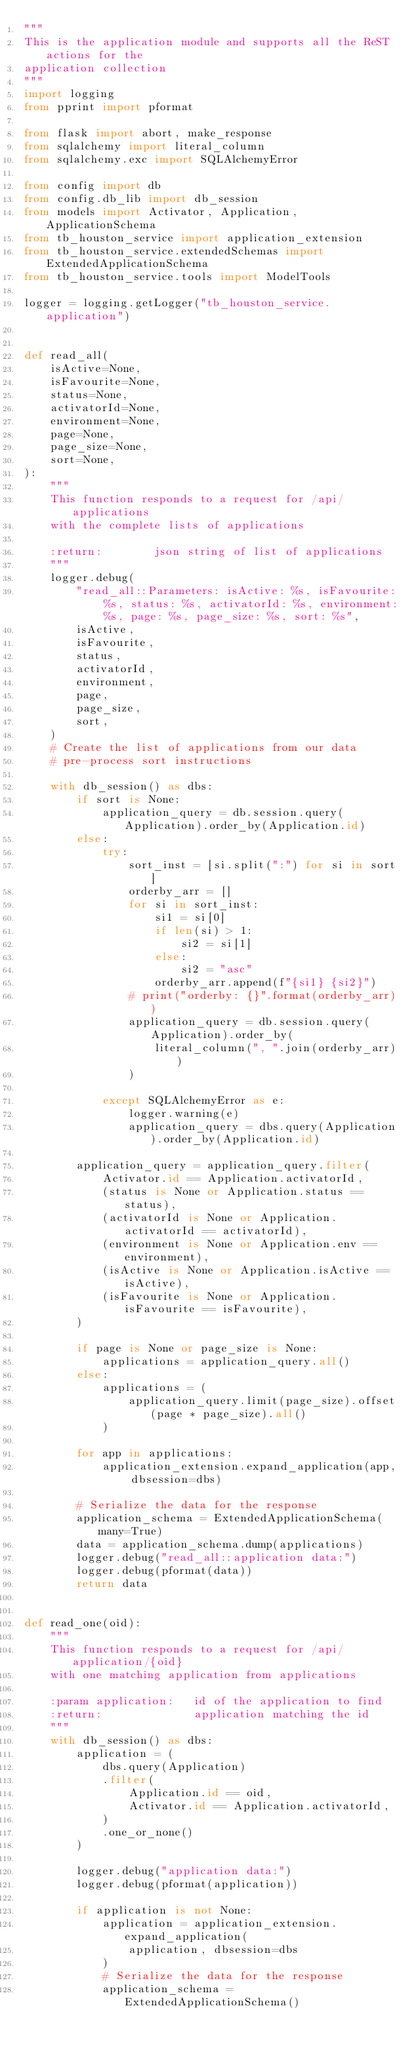Convert code to text. <code><loc_0><loc_0><loc_500><loc_500><_Python_>"""
This is the application module and supports all the ReST actions for the
application collection
"""
import logging
from pprint import pformat

from flask import abort, make_response
from sqlalchemy import literal_column
from sqlalchemy.exc import SQLAlchemyError

from config import db
from config.db_lib import db_session
from models import Activator, Application, ApplicationSchema
from tb_houston_service import application_extension
from tb_houston_service.extendedSchemas import ExtendedApplicationSchema
from tb_houston_service.tools import ModelTools

logger = logging.getLogger("tb_houston_service.application")


def read_all(
    isActive=None,
    isFavourite=None,
    status=None,
    activatorId=None,
    environment=None,
    page=None,
    page_size=None,
    sort=None,
):
    """
    This function responds to a request for /api/applications
    with the complete lists of applications

    :return:        json string of list of applications
    """
    logger.debug(
        "read_all::Parameters: isActive: %s, isFavourite: %s, status: %s, activatorId: %s, environment: %s, page: %s, page_size: %s, sort: %s",
        isActive,
        isFavourite,
        status,
        activatorId,
        environment,
        page,
        page_size,
        sort,
    )
    # Create the list of applications from our data
    # pre-process sort instructions

    with db_session() as dbs:
        if sort is None:
            application_query = db.session.query(Application).order_by(Application.id)
        else:
            try:
                sort_inst = [si.split(":") for si in sort]
                orderby_arr = []
                for si in sort_inst:
                    si1 = si[0]
                    if len(si) > 1:
                        si2 = si[1]
                    else:
                        si2 = "asc"
                    orderby_arr.append(f"{si1} {si2}")
                # print("orderby: {}".format(orderby_arr))
                application_query = db.session.query(Application).order_by(
                    literal_column(", ".join(orderby_arr))
                )

            except SQLAlchemyError as e:
                logger.warning(e)
                application_query = dbs.query(Application).order_by(Application.id)

        application_query = application_query.filter(
            Activator.id == Application.activatorId,
            (status is None or Application.status == status),
            (activatorId is None or Application.activatorId == activatorId),
            (environment is None or Application.env == environment),
            (isActive is None or Application.isActive == isActive),
            (isFavourite is None or Application.isFavourite == isFavourite),
        )

        if page is None or page_size is None:
            applications = application_query.all()
        else:
            applications = (
                application_query.limit(page_size).offset(page * page_size).all()
            )

        for app in applications:
            application_extension.expand_application(app, dbsession=dbs)

        # Serialize the data for the response
        application_schema = ExtendedApplicationSchema(many=True)
        data = application_schema.dump(applications)
        logger.debug("read_all::application data:")
        logger.debug(pformat(data))
        return data


def read_one(oid):
    """
    This function responds to a request for /api/application/{oid}
    with one matching application from applications

    :param application:   id of the application to find
    :return:              application matching the id
    """
    with db_session() as dbs:
        application = (
            dbs.query(Application)
            .filter(
                Application.id == oid,
                Activator.id == Application.activatorId,
            )
            .one_or_none()
        )

        logger.debug("application data:")
        logger.debug(pformat(application))

        if application is not None:
            application = application_extension.expand_application(
                application, dbsession=dbs
            )
            # Serialize the data for the response
            application_schema = ExtendedApplicationSchema()</code> 